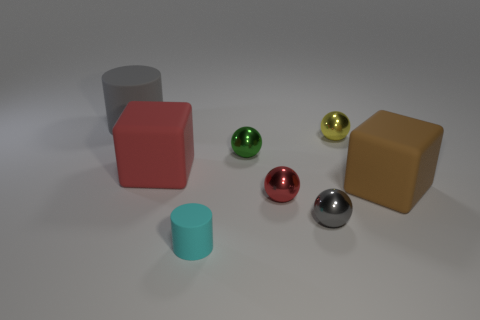There is a big object that is to the right of the yellow ball; how many tiny metallic objects are in front of it?
Provide a succinct answer. 2. What number of things are cubes that are to the left of the small yellow ball or large gray matte cylinders?
Keep it short and to the point. 2. What number of large green cylinders are the same material as the tiny green ball?
Make the answer very short. 0. There is a metal object that is the same color as the large rubber cylinder; what shape is it?
Provide a succinct answer. Sphere. Are there an equal number of yellow balls that are right of the tiny yellow object and tiny blue rubber blocks?
Provide a succinct answer. Yes. There is a red object that is on the right side of the cyan rubber thing; how big is it?
Offer a very short reply. Small. What number of small objects are either green cylinders or red matte cubes?
Make the answer very short. 0. What color is the big matte object that is the same shape as the small cyan object?
Provide a short and direct response. Gray. Does the red shiny ball have the same size as the brown thing?
Your answer should be very brief. No. How many things are rubber objects or shiny spheres to the left of the small gray object?
Give a very brief answer. 6. 